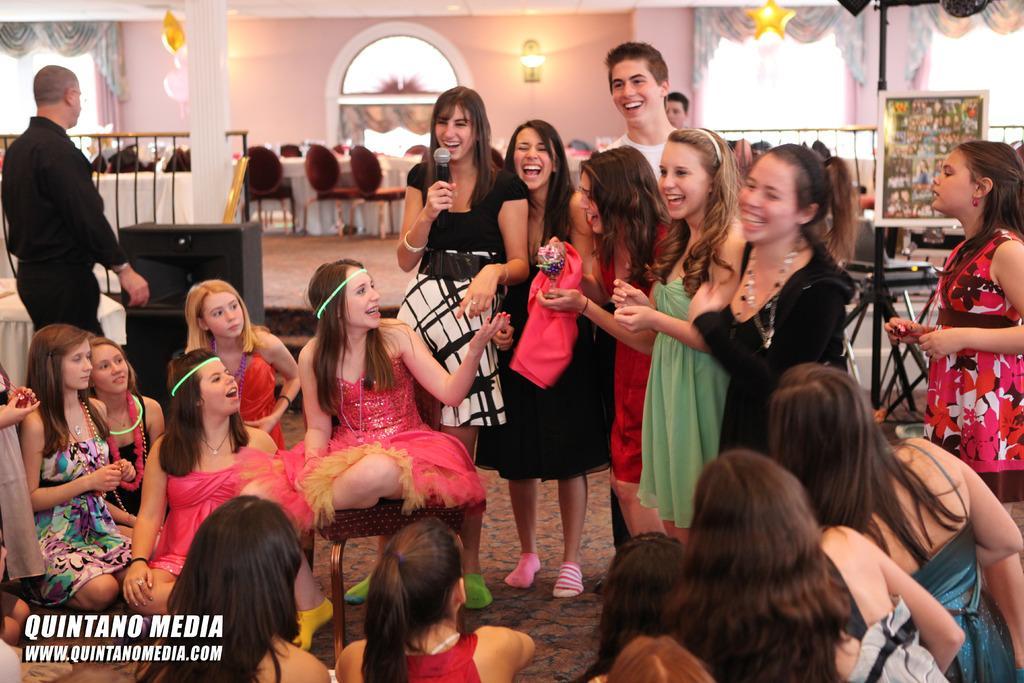In one or two sentences, can you explain what this image depicts? This picture describes about group of people, few are seated, few are standing and few are smiling, in the middle of the image we can see a woman, she is holding a microphone in her hand, in the background we can see few metal rods, lights, curtains, chairs and a dining table. 